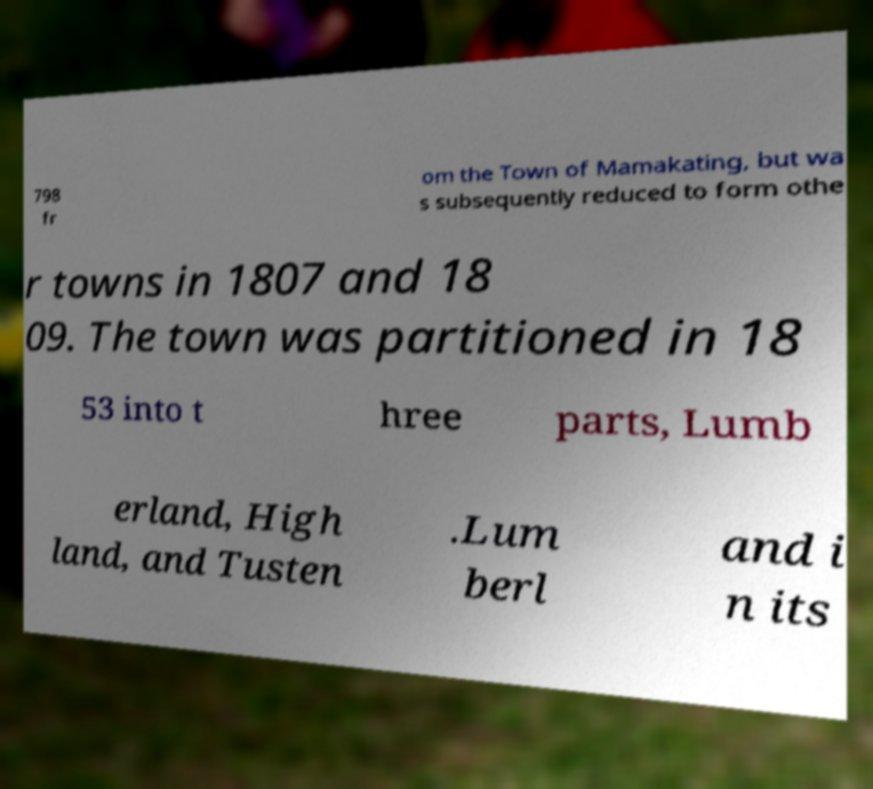For documentation purposes, I need the text within this image transcribed. Could you provide that? 798 fr om the Town of Mamakating, but wa s subsequently reduced to form othe r towns in 1807 and 18 09. The town was partitioned in 18 53 into t hree parts, Lumb erland, High land, and Tusten .Lum berl and i n its 